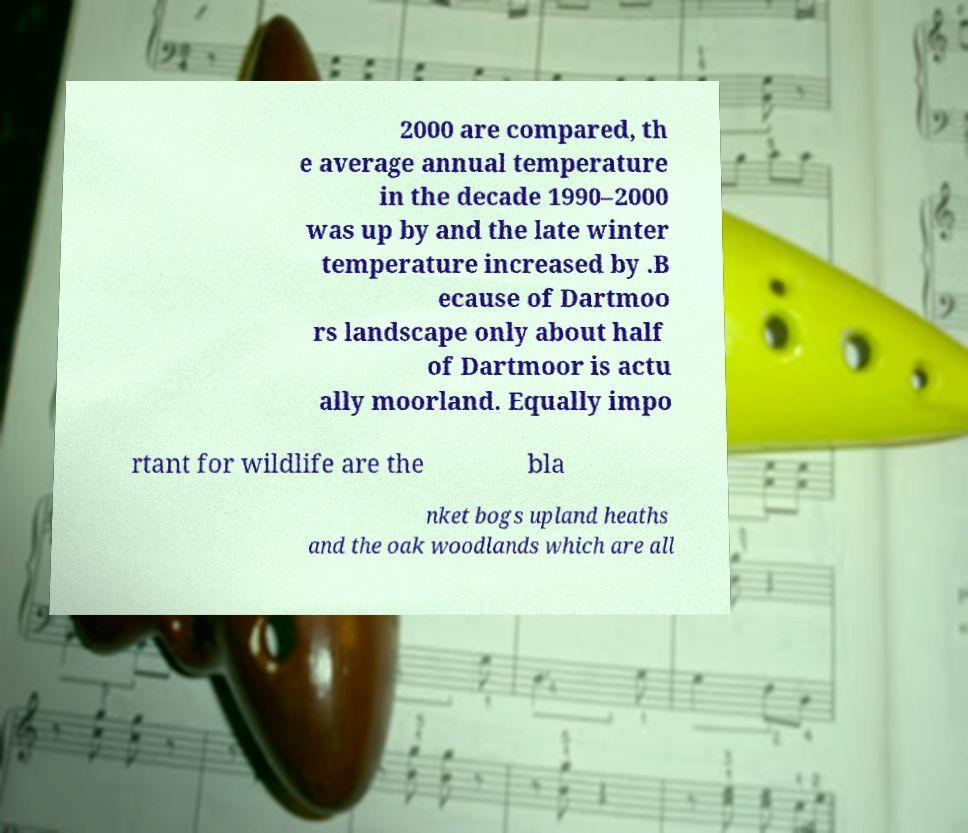For documentation purposes, I need the text within this image transcribed. Could you provide that? 2000 are compared, th e average annual temperature in the decade 1990–2000 was up by and the late winter temperature increased by .B ecause of Dartmoo rs landscape only about half of Dartmoor is actu ally moorland. Equally impo rtant for wildlife are the bla nket bogs upland heaths and the oak woodlands which are all 